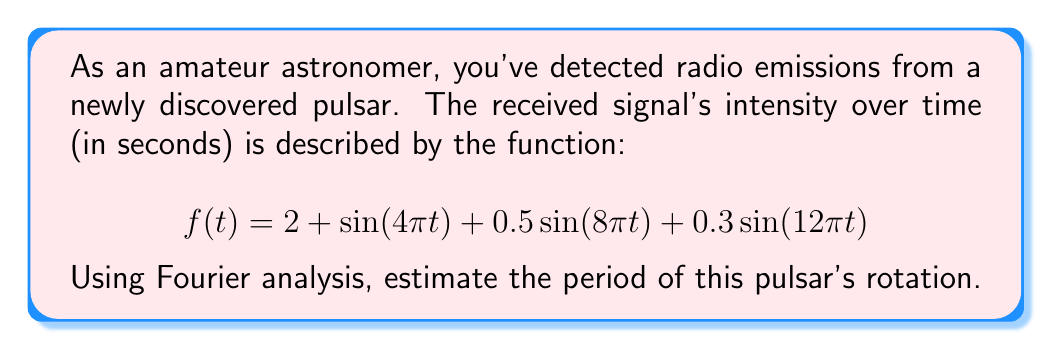What is the answer to this math problem? To estimate the pulsar's rotation period using Fourier analysis, we need to follow these steps:

1) Identify the fundamental frequency:
   The Fourier series representation of the signal shows three sinusoidal components:
   $$2 + \sin(4\pi t) + 0.5\sin(8\pi t) + 0.3\sin(12\pi t)$$

2) The angular frequencies of these components are:
   $$\omega_1 = 4\pi, \omega_2 = 8\pi, \omega_3 = 12\pi$$

3) The fundamental frequency is the greatest common divisor (GCD) of these frequencies:
   $$\omega_0 = GCD(4\pi, 8\pi, 12\pi) = 4\pi$$

4) The fundamental frequency $\omega_0$ relates to the period $T$ by:
   $$\omega_0 = \frac{2\pi}{T}$$

5) Solving for $T$:
   $$T = \frac{2\pi}{\omega_0} = \frac{2\pi}{4\pi} = \frac{1}{2}$$

Therefore, the estimated period of the pulsar's rotation is 0.5 seconds.
Answer: 0.5 seconds 